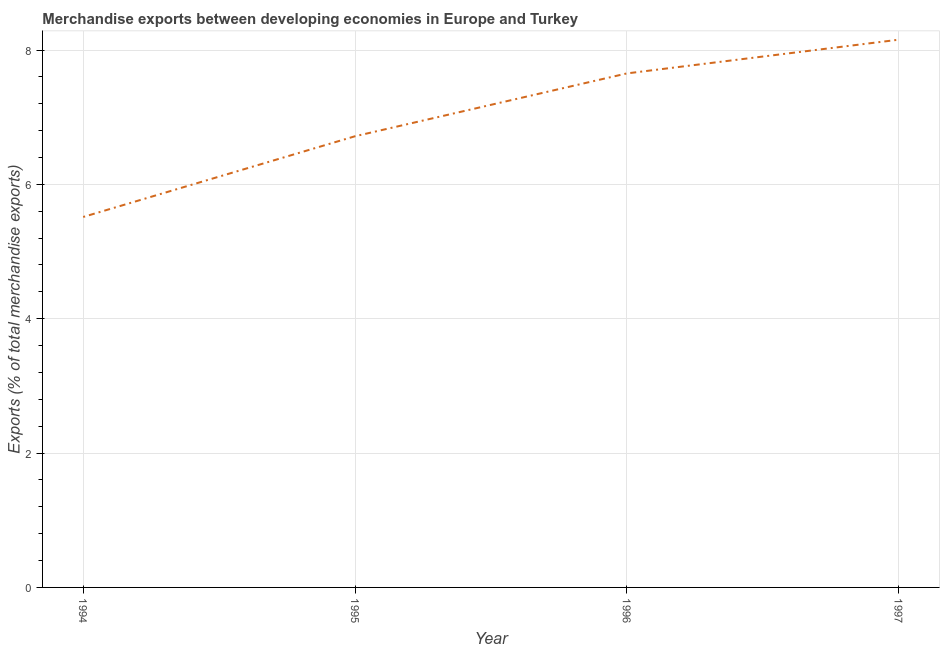What is the merchandise exports in 1996?
Ensure brevity in your answer.  7.65. Across all years, what is the maximum merchandise exports?
Offer a very short reply. 8.15. Across all years, what is the minimum merchandise exports?
Make the answer very short. 5.51. In which year was the merchandise exports maximum?
Your response must be concise. 1997. What is the sum of the merchandise exports?
Provide a succinct answer. 28.04. What is the difference between the merchandise exports in 1994 and 1995?
Your answer should be compact. -1.2. What is the average merchandise exports per year?
Provide a short and direct response. 7.01. What is the median merchandise exports?
Your response must be concise. 7.18. In how many years, is the merchandise exports greater than 3.2 %?
Keep it short and to the point. 4. What is the ratio of the merchandise exports in 1995 to that in 1996?
Offer a very short reply. 0.88. Is the merchandise exports in 1994 less than that in 1997?
Make the answer very short. Yes. What is the difference between the highest and the second highest merchandise exports?
Ensure brevity in your answer.  0.5. What is the difference between the highest and the lowest merchandise exports?
Your answer should be very brief. 2.64. What is the title of the graph?
Your answer should be very brief. Merchandise exports between developing economies in Europe and Turkey. What is the label or title of the Y-axis?
Offer a terse response. Exports (% of total merchandise exports). What is the Exports (% of total merchandise exports) in 1994?
Keep it short and to the point. 5.51. What is the Exports (% of total merchandise exports) in 1995?
Provide a short and direct response. 6.72. What is the Exports (% of total merchandise exports) in 1996?
Your answer should be compact. 7.65. What is the Exports (% of total merchandise exports) of 1997?
Provide a succinct answer. 8.15. What is the difference between the Exports (% of total merchandise exports) in 1994 and 1995?
Your answer should be very brief. -1.2. What is the difference between the Exports (% of total merchandise exports) in 1994 and 1996?
Your answer should be very brief. -2.14. What is the difference between the Exports (% of total merchandise exports) in 1994 and 1997?
Make the answer very short. -2.64. What is the difference between the Exports (% of total merchandise exports) in 1995 and 1996?
Your answer should be very brief. -0.94. What is the difference between the Exports (% of total merchandise exports) in 1995 and 1997?
Offer a terse response. -1.44. What is the difference between the Exports (% of total merchandise exports) in 1996 and 1997?
Make the answer very short. -0.5. What is the ratio of the Exports (% of total merchandise exports) in 1994 to that in 1995?
Ensure brevity in your answer.  0.82. What is the ratio of the Exports (% of total merchandise exports) in 1994 to that in 1996?
Provide a short and direct response. 0.72. What is the ratio of the Exports (% of total merchandise exports) in 1994 to that in 1997?
Your response must be concise. 0.68. What is the ratio of the Exports (% of total merchandise exports) in 1995 to that in 1996?
Offer a very short reply. 0.88. What is the ratio of the Exports (% of total merchandise exports) in 1995 to that in 1997?
Your answer should be compact. 0.82. What is the ratio of the Exports (% of total merchandise exports) in 1996 to that in 1997?
Your response must be concise. 0.94. 